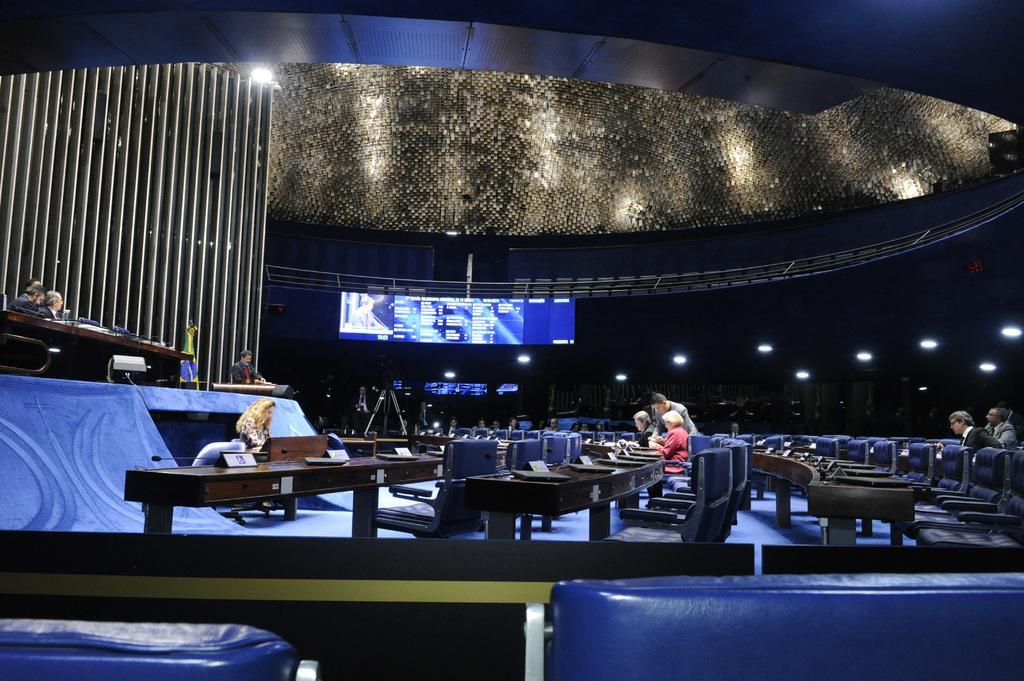Describe this image in one or two sentences. In this image there are chairs few people are sitting on chairs, in front of the chairs there is a stage on that stage there are people sitting on chairs, in front of them there are tables, in the background there is a screen on top there are lights. 